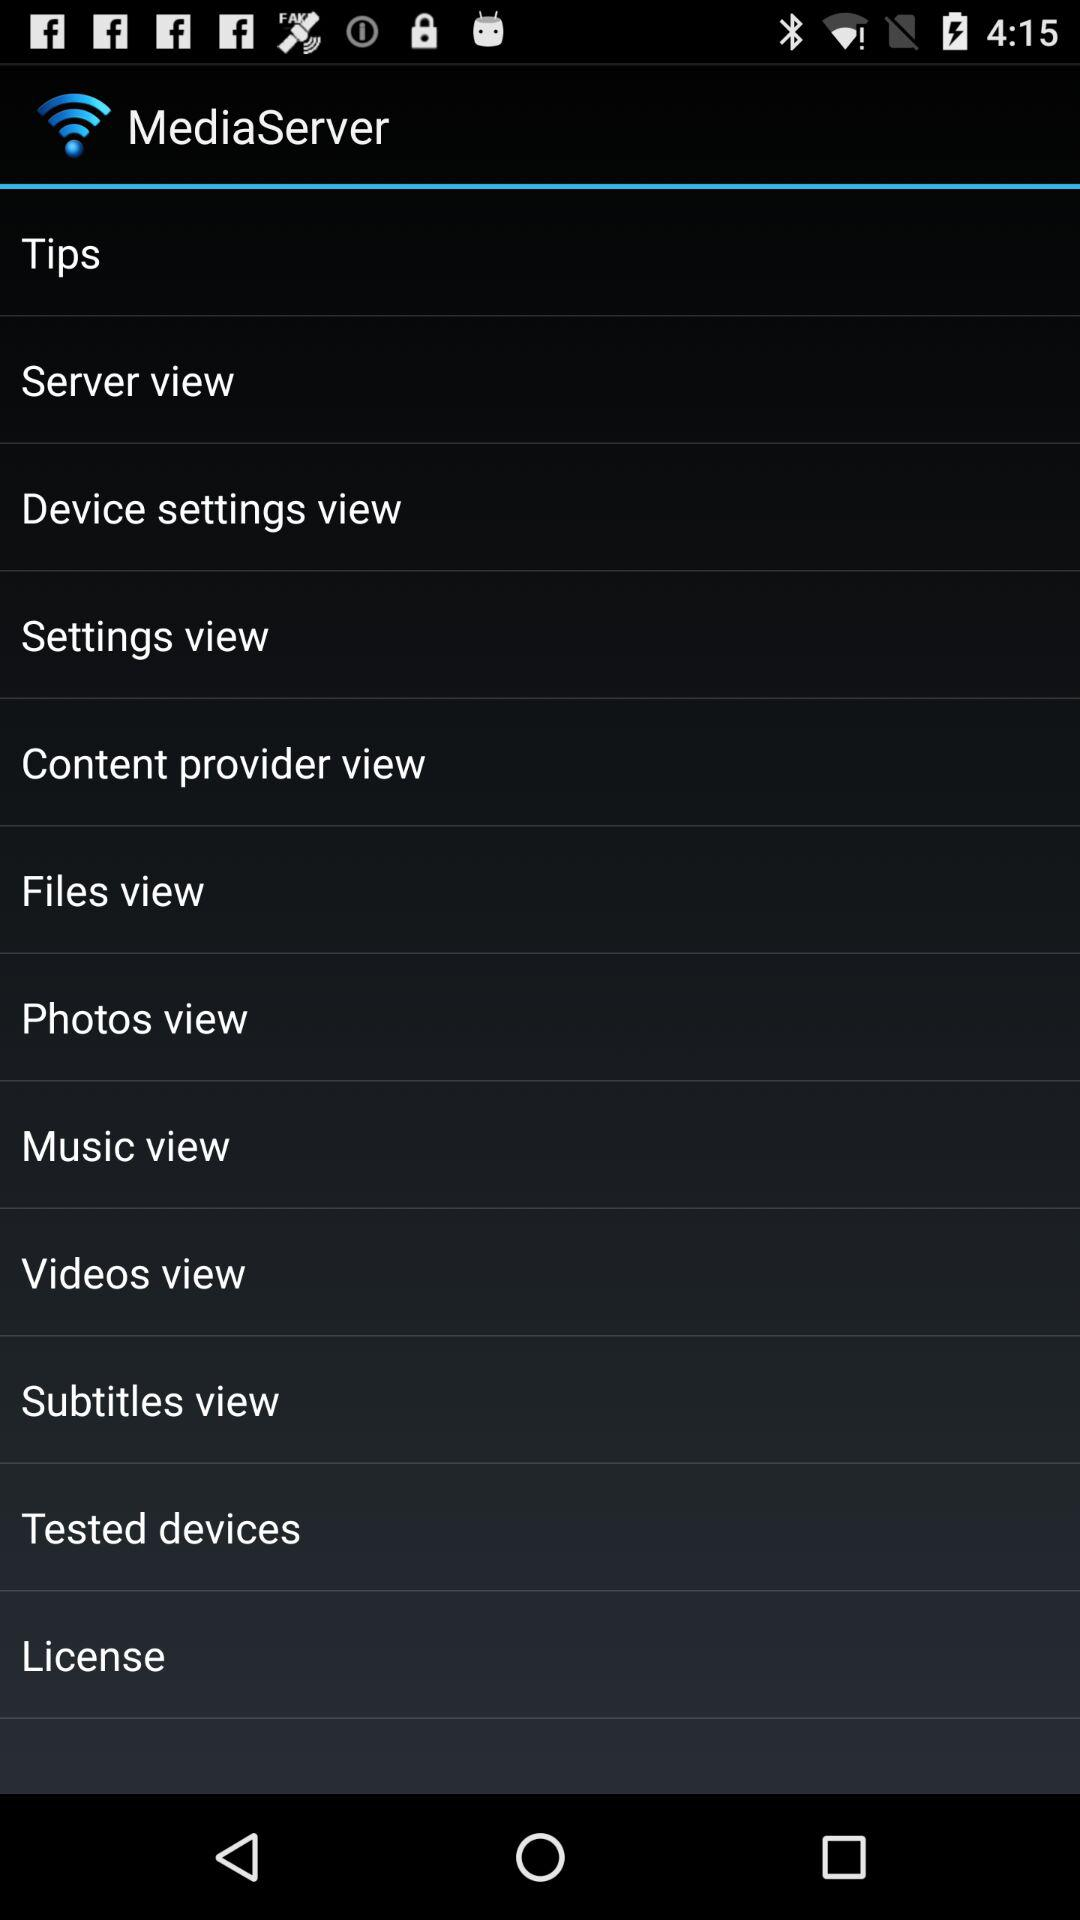What is the name of the application? The name of the application is "MediaServer". 